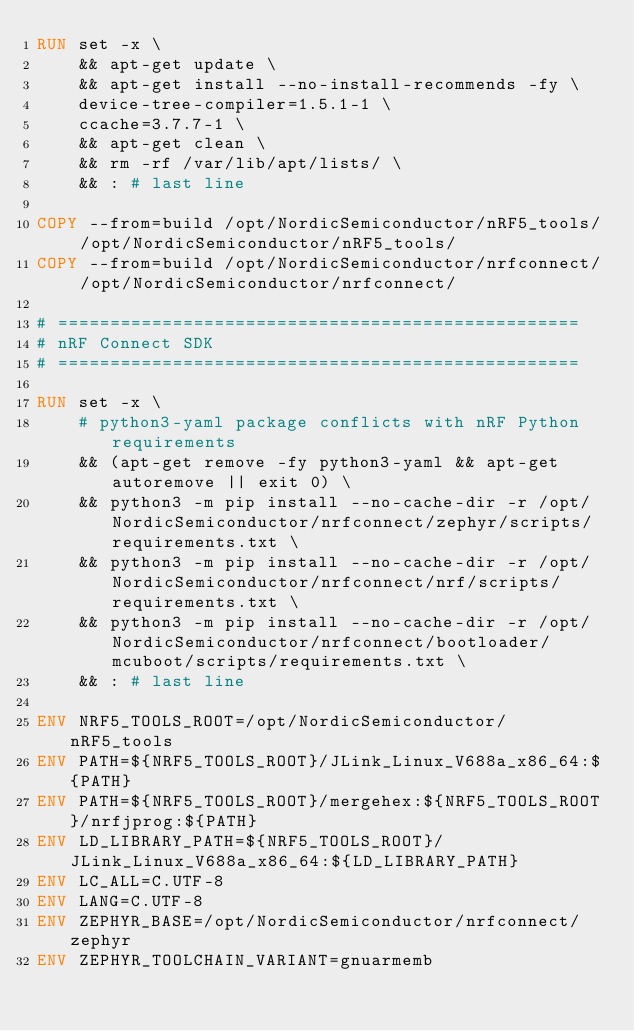Convert code to text. <code><loc_0><loc_0><loc_500><loc_500><_Dockerfile_>RUN set -x \
    && apt-get update \
    && apt-get install --no-install-recommends -fy \
    device-tree-compiler=1.5.1-1 \
    ccache=3.7.7-1 \
    && apt-get clean \
    && rm -rf /var/lib/apt/lists/ \
    && : # last line

COPY --from=build /opt/NordicSemiconductor/nRF5_tools/ /opt/NordicSemiconductor/nRF5_tools/
COPY --from=build /opt/NordicSemiconductor/nrfconnect/ /opt/NordicSemiconductor/nrfconnect/

# ==================================================
# nRF Connect SDK
# ==================================================

RUN set -x \
    # python3-yaml package conflicts with nRF Python requirements
    && (apt-get remove -fy python3-yaml && apt-get autoremove || exit 0) \
    && python3 -m pip install --no-cache-dir -r /opt/NordicSemiconductor/nrfconnect/zephyr/scripts/requirements.txt \
    && python3 -m pip install --no-cache-dir -r /opt/NordicSemiconductor/nrfconnect/nrf/scripts/requirements.txt \
    && python3 -m pip install --no-cache-dir -r /opt/NordicSemiconductor/nrfconnect/bootloader/mcuboot/scripts/requirements.txt \
    && : # last line

ENV NRF5_TOOLS_ROOT=/opt/NordicSemiconductor/nRF5_tools
ENV PATH=${NRF5_TOOLS_ROOT}/JLink_Linux_V688a_x86_64:${PATH}
ENV PATH=${NRF5_TOOLS_ROOT}/mergehex:${NRF5_TOOLS_ROOT}/nrfjprog:${PATH}
ENV LD_LIBRARY_PATH=${NRF5_TOOLS_ROOT}/JLink_Linux_V688a_x86_64:${LD_LIBRARY_PATH}
ENV LC_ALL=C.UTF-8
ENV LANG=C.UTF-8
ENV ZEPHYR_BASE=/opt/NordicSemiconductor/nrfconnect/zephyr
ENV ZEPHYR_TOOLCHAIN_VARIANT=gnuarmemb
</code> 